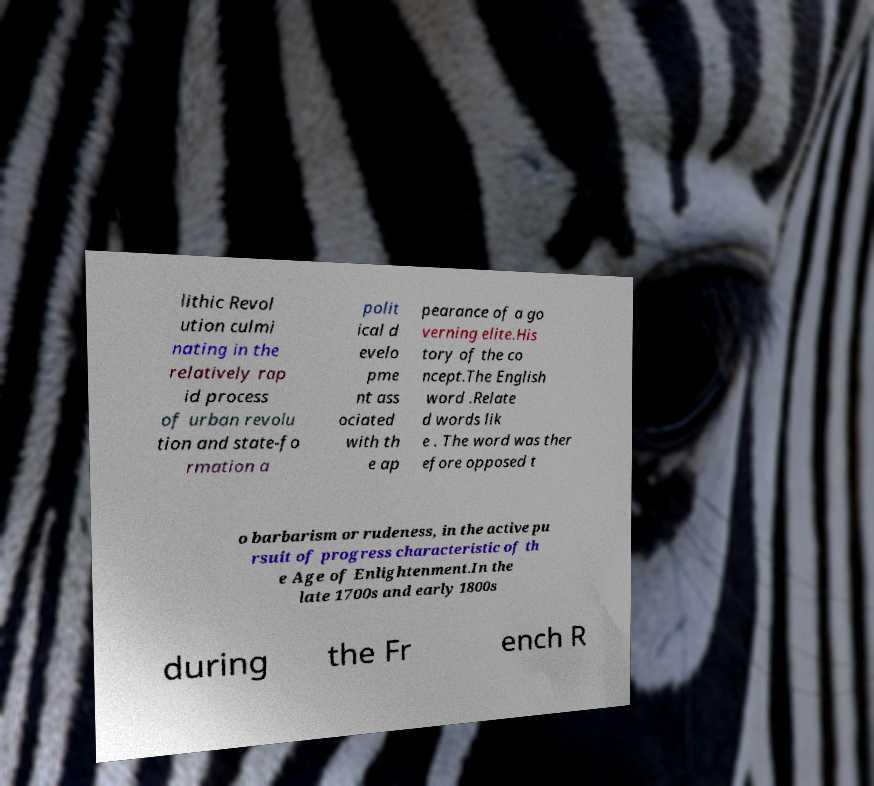Please read and relay the text visible in this image. What does it say? lithic Revol ution culmi nating in the relatively rap id process of urban revolu tion and state-fo rmation a polit ical d evelo pme nt ass ociated with th e ap pearance of a go verning elite.His tory of the co ncept.The English word .Relate d words lik e . The word was ther efore opposed t o barbarism or rudeness, in the active pu rsuit of progress characteristic of th e Age of Enlightenment.In the late 1700s and early 1800s during the Fr ench R 